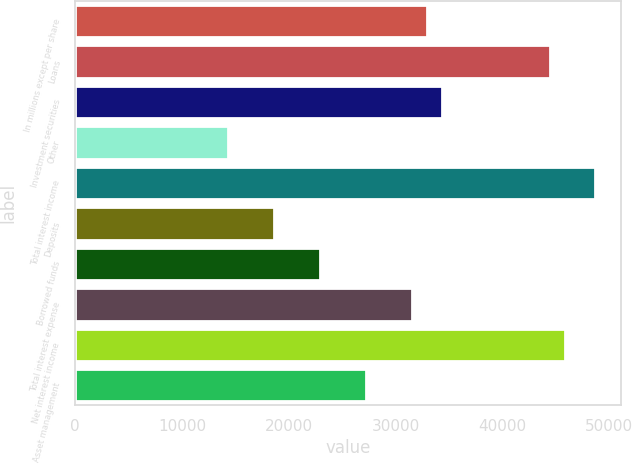<chart> <loc_0><loc_0><loc_500><loc_500><bar_chart><fcel>In millions except per share<fcel>Loans<fcel>Investment securities<fcel>Other<fcel>Total interest income<fcel>Deposits<fcel>Borrowed funds<fcel>Total interest expense<fcel>Net interest income<fcel>Asset management<nl><fcel>32947.2<fcel>44406.4<fcel>34379.6<fcel>14326<fcel>48703.6<fcel>18623.2<fcel>22920.4<fcel>31514.8<fcel>45838.8<fcel>27217.6<nl></chart> 